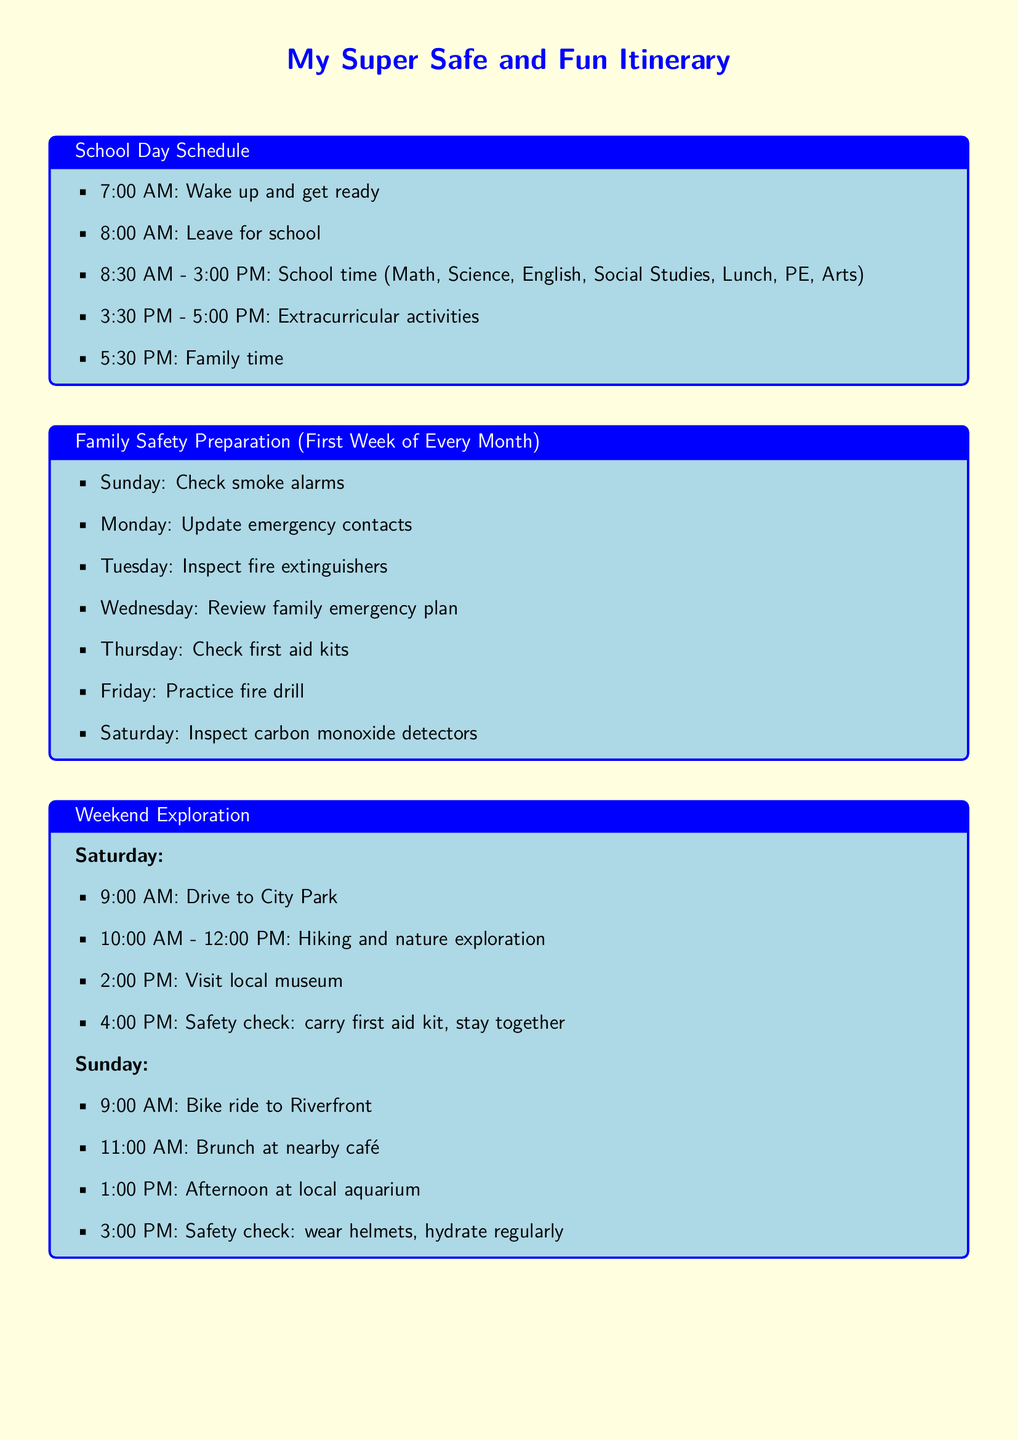What time does school start? The document states that school starts at 8:30 AM.
Answer: 8:30 AM What day are fire drills practiced? According to the Family Safety Preparation section, fire drills are practiced on Fridays.
Answer: Friday What is the duration of extracurricular activities? Extracurricular activities take place from 3:30 PM to 5:00 PM, which is a duration of 1.5 hours.
Answer: 1.5 hours What is the first activity listed for Saturday in Weekend Exploration? The first activity listed is driving to City Park at 9:00 AM.
Answer: Drive to City Park How often is the Device Security Routine performed? The Device Security Routine is performed every month, as indicated in the document.
Answer: Monthly What time is the family homework scheduled during weekdays? The homework schedule during weekdays is from 4:00 PM to 6:30 PM.
Answer: 4:00 PM - 6:30 PM On which day do they check carbon monoxide detectors? Carbon monoxide detectors are checked on Saturday according to the Family Safety Preparation section.
Answer: Saturday What is one safety precaution mentioned for the Sunday bike ride? The safety precaution mentioned is to wear helmets.
Answer: Wear helmets What is one of the activities scheduled for Sunday in Weekend Exploration? One of the activities is visiting the local aquarium at 1:00 PM.
Answer: Visit local aquarium 